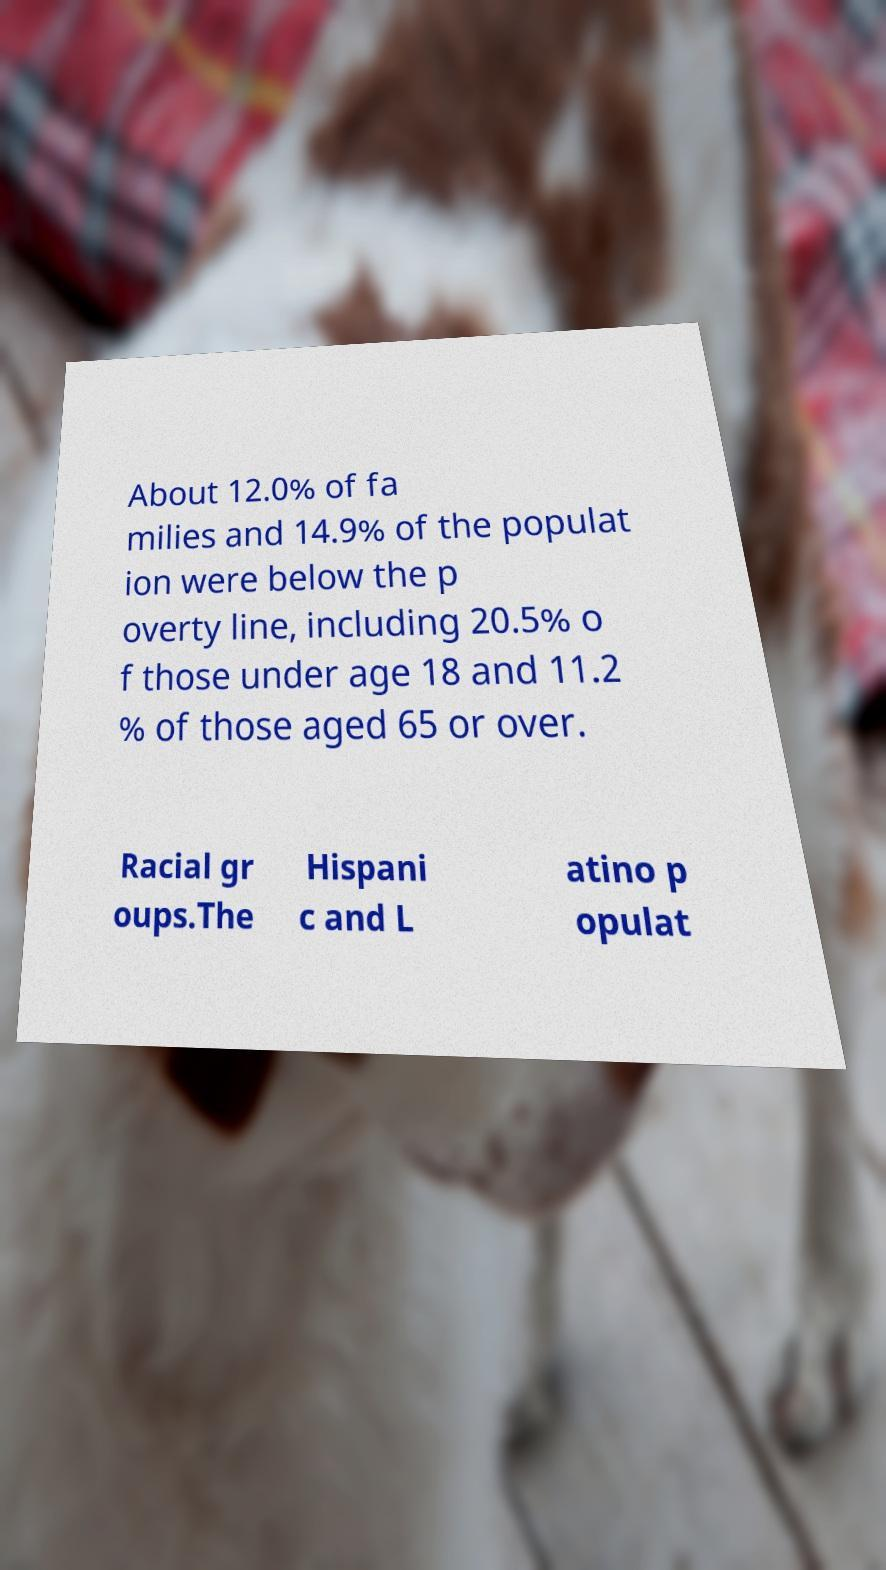For documentation purposes, I need the text within this image transcribed. Could you provide that? About 12.0% of fa milies and 14.9% of the populat ion were below the p overty line, including 20.5% o f those under age 18 and 11.2 % of those aged 65 or over. Racial gr oups.The Hispani c and L atino p opulat 